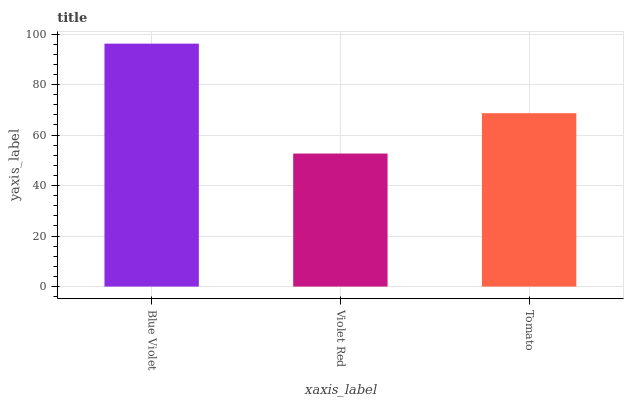Is Violet Red the minimum?
Answer yes or no. Yes. Is Blue Violet the maximum?
Answer yes or no. Yes. Is Tomato the minimum?
Answer yes or no. No. Is Tomato the maximum?
Answer yes or no. No. Is Tomato greater than Violet Red?
Answer yes or no. Yes. Is Violet Red less than Tomato?
Answer yes or no. Yes. Is Violet Red greater than Tomato?
Answer yes or no. No. Is Tomato less than Violet Red?
Answer yes or no. No. Is Tomato the high median?
Answer yes or no. Yes. Is Tomato the low median?
Answer yes or no. Yes. Is Blue Violet the high median?
Answer yes or no. No. Is Blue Violet the low median?
Answer yes or no. No. 